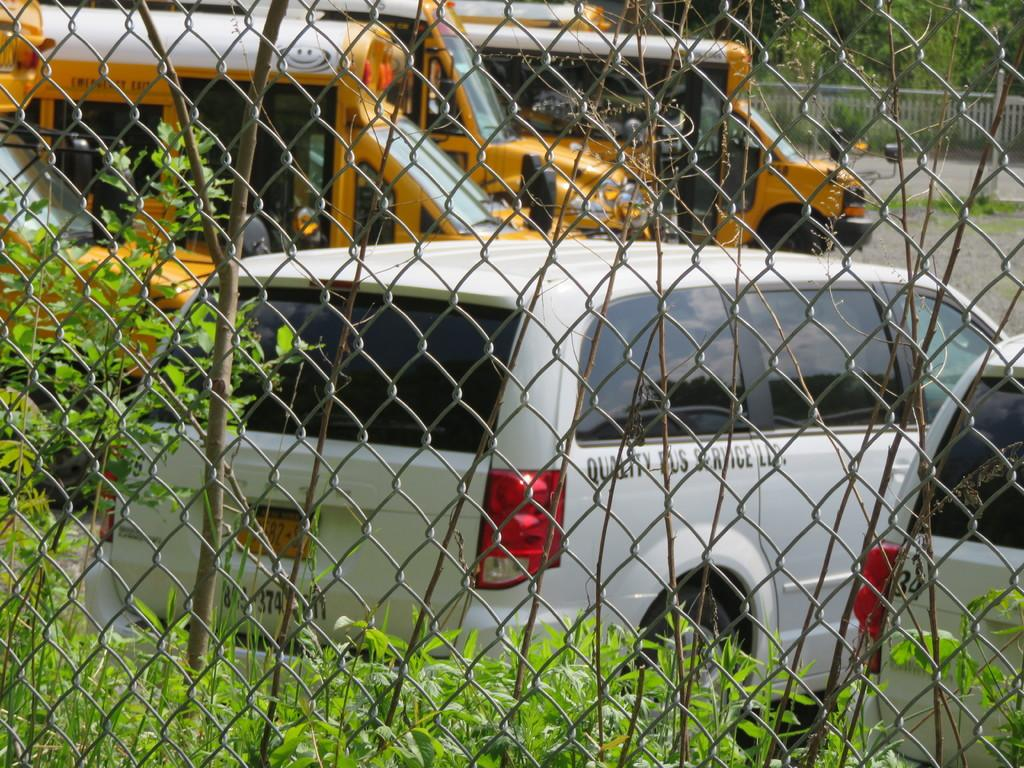What types of vehicles can be seen behind the fence in the image? There are cars and buses behind the fence in the image. What is located at the back of the image? There are trees at the back of the image. What feature is present in the image that might be used for safety or support? There is a railing in the image. What can be seen at the bottom of the image? There is a road at the bottom of the image. What type of vegetation is present in the image? There is grass in the image. What title is written on the pump in the image? There is no pump present in the image. What type of cap is visible on the person in the image? There is no person or cap visible in the image. 